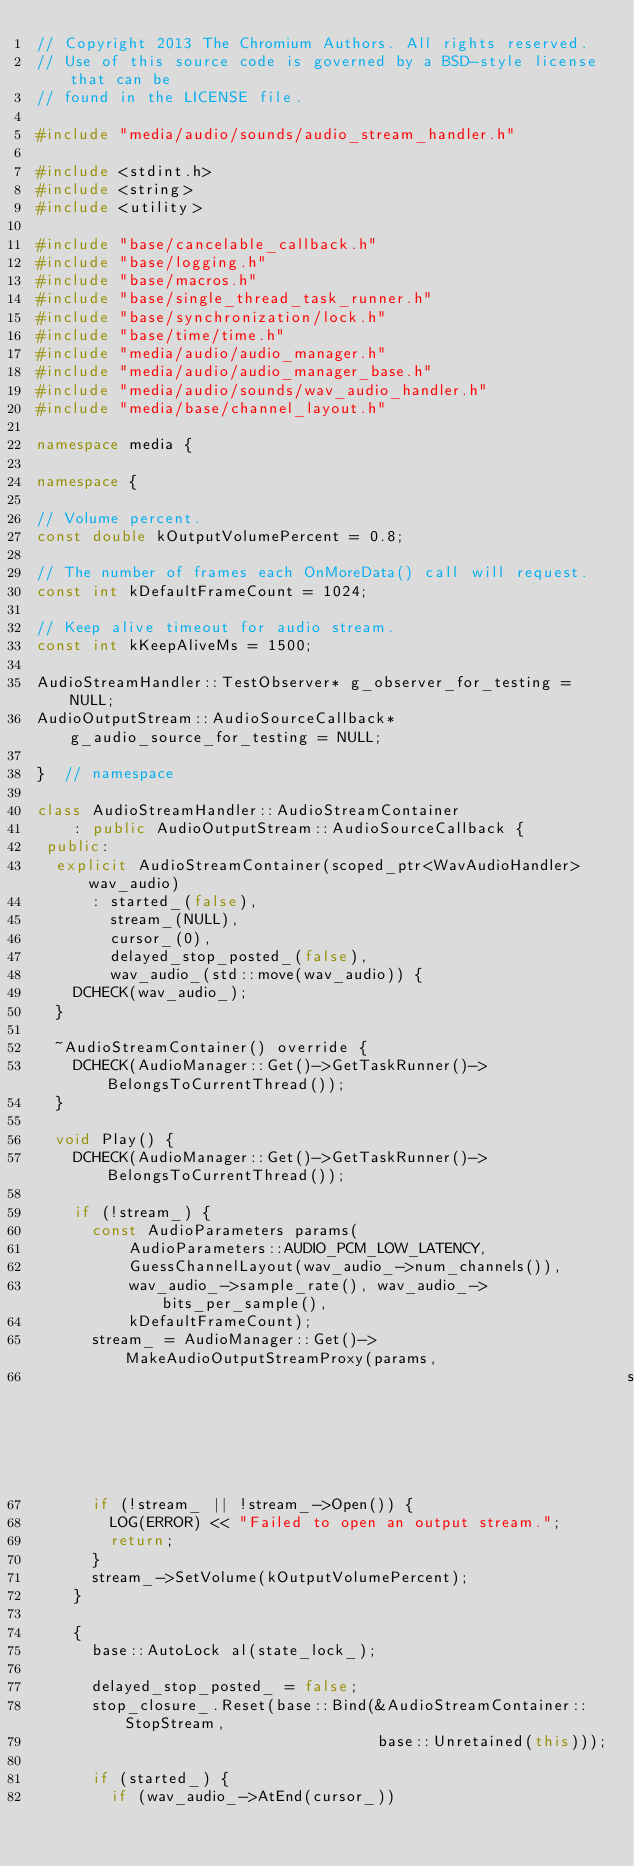<code> <loc_0><loc_0><loc_500><loc_500><_C++_>// Copyright 2013 The Chromium Authors. All rights reserved.
// Use of this source code is governed by a BSD-style license that can be
// found in the LICENSE file.

#include "media/audio/sounds/audio_stream_handler.h"

#include <stdint.h>
#include <string>
#include <utility>

#include "base/cancelable_callback.h"
#include "base/logging.h"
#include "base/macros.h"
#include "base/single_thread_task_runner.h"
#include "base/synchronization/lock.h"
#include "base/time/time.h"
#include "media/audio/audio_manager.h"
#include "media/audio/audio_manager_base.h"
#include "media/audio/sounds/wav_audio_handler.h"
#include "media/base/channel_layout.h"

namespace media {

namespace {

// Volume percent.
const double kOutputVolumePercent = 0.8;

// The number of frames each OnMoreData() call will request.
const int kDefaultFrameCount = 1024;

// Keep alive timeout for audio stream.
const int kKeepAliveMs = 1500;

AudioStreamHandler::TestObserver* g_observer_for_testing = NULL;
AudioOutputStream::AudioSourceCallback* g_audio_source_for_testing = NULL;

}  // namespace

class AudioStreamHandler::AudioStreamContainer
    : public AudioOutputStream::AudioSourceCallback {
 public:
  explicit AudioStreamContainer(scoped_ptr<WavAudioHandler> wav_audio)
      : started_(false),
        stream_(NULL),
        cursor_(0),
        delayed_stop_posted_(false),
        wav_audio_(std::move(wav_audio)) {
    DCHECK(wav_audio_);
  }

  ~AudioStreamContainer() override {
    DCHECK(AudioManager::Get()->GetTaskRunner()->BelongsToCurrentThread());
  }

  void Play() {
    DCHECK(AudioManager::Get()->GetTaskRunner()->BelongsToCurrentThread());

    if (!stream_) {
      const AudioParameters params(
          AudioParameters::AUDIO_PCM_LOW_LATENCY,
          GuessChannelLayout(wav_audio_->num_channels()),
          wav_audio_->sample_rate(), wav_audio_->bits_per_sample(),
          kDefaultFrameCount);
      stream_ = AudioManager::Get()->MakeAudioOutputStreamProxy(params,
                                                                std::string());
      if (!stream_ || !stream_->Open()) {
        LOG(ERROR) << "Failed to open an output stream.";
        return;
      }
      stream_->SetVolume(kOutputVolumePercent);
    }

    {
      base::AutoLock al(state_lock_);

      delayed_stop_posted_ = false;
      stop_closure_.Reset(base::Bind(&AudioStreamContainer::StopStream,
                                     base::Unretained(this)));

      if (started_) {
        if (wav_audio_->AtEnd(cursor_))</code> 